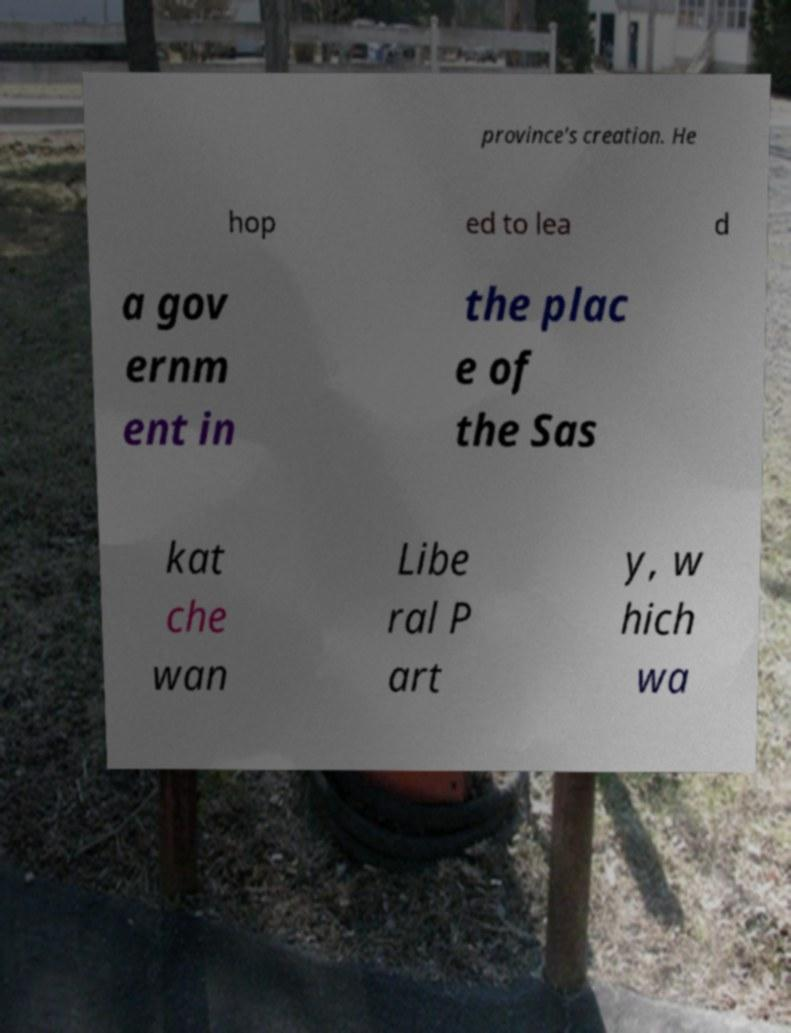Please identify and transcribe the text found in this image. province's creation. He hop ed to lea d a gov ernm ent in the plac e of the Sas kat che wan Libe ral P art y, w hich wa 